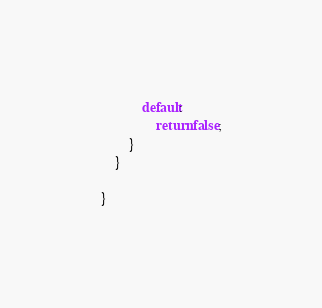<code> <loc_0><loc_0><loc_500><loc_500><_Java_>            default:
                return false;
        }
    }

}
</code> 